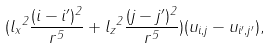<formula> <loc_0><loc_0><loc_500><loc_500>( { l _ { x } } ^ { 2 } \frac { ( i - i ^ { \prime } ) ^ { 2 } } { r ^ { 5 } } + { l _ { z } } ^ { 2 } \frac { ( j - j ^ { \prime } ) ^ { 2 } } { r ^ { 5 } } ) ( u _ { i , j } - u _ { i ^ { \prime } , j ^ { \prime } } ) ,</formula> 